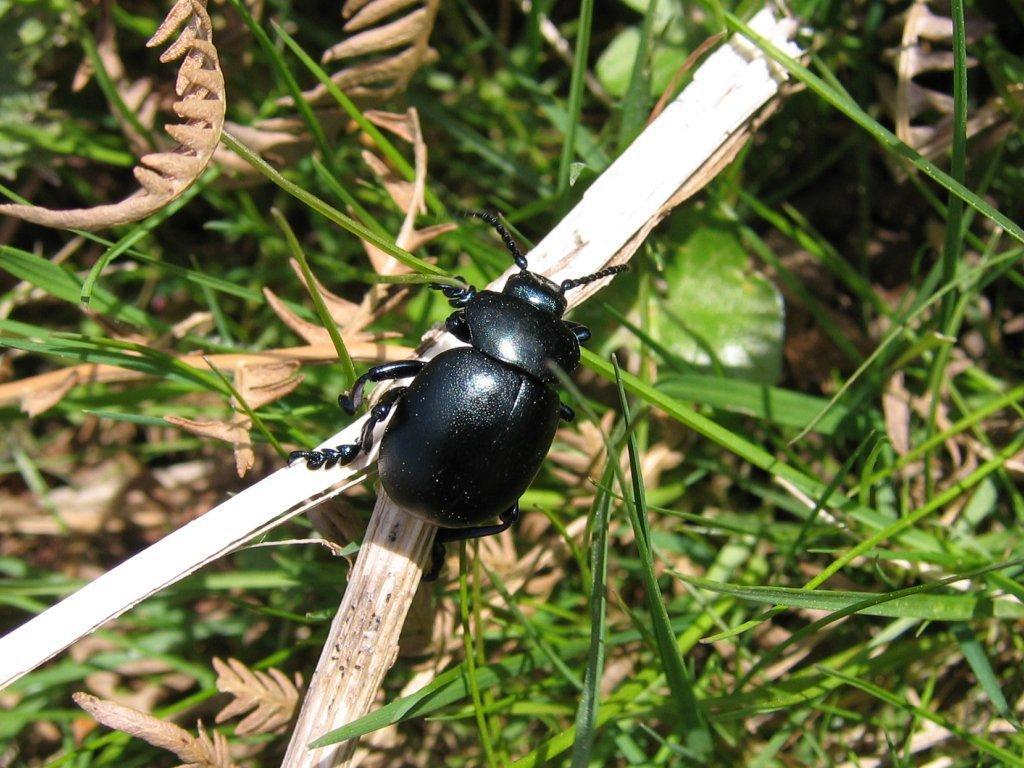Could you give a brief overview of what you see in this image? In this image there is an insect on the stick, there are few leaves and grass. 